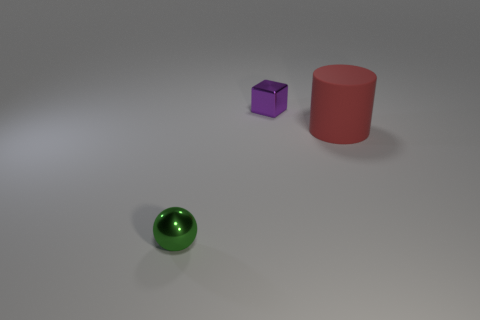Add 1 green metallic spheres. How many objects exist? 4 Subtract all blocks. How many objects are left? 2 Add 1 tiny shiny blocks. How many tiny shiny blocks exist? 2 Subtract 0 brown balls. How many objects are left? 3 Subtract all large red metallic cylinders. Subtract all purple shiny things. How many objects are left? 2 Add 2 big red rubber things. How many big red rubber things are left? 3 